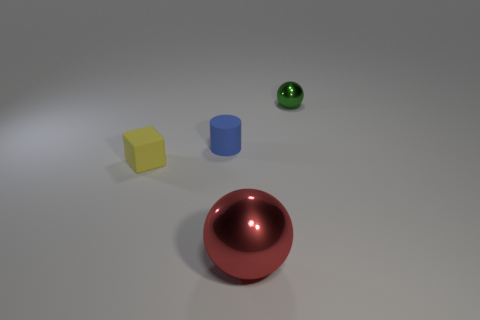What number of rubber things are either large brown balls or cylinders?
Your response must be concise. 1. Are there any small blue cylinders in front of the sphere that is on the right side of the ball in front of the tiny green thing?
Give a very brief answer. Yes. What number of large red balls are behind the tiny blue object?
Your response must be concise. 0. What number of small things are purple balls or objects?
Provide a short and direct response. 3. What is the shape of the tiny object behind the tiny cylinder?
Make the answer very short. Sphere. There is a metal sphere that is in front of the blue rubber object; does it have the same size as the cube that is on the left side of the red metallic object?
Offer a terse response. No. Is the number of red spheres to the right of the blue thing greater than the number of big red metal spheres in front of the large red ball?
Your answer should be compact. Yes. Is there a cylinder that has the same material as the cube?
Ensure brevity in your answer.  Yes. What is the tiny thing that is both in front of the tiny metal sphere and to the right of the yellow rubber cube made of?
Provide a succinct answer. Rubber. The large metal object is what color?
Your answer should be compact. Red. 